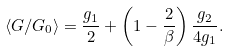Convert formula to latex. <formula><loc_0><loc_0><loc_500><loc_500>\langle G / G _ { 0 } \rangle = \frac { g _ { 1 } } { 2 } + \left ( 1 - \frac { 2 } { \beta } \right ) \frac { g _ { 2 } } { 4 g _ { 1 } } .</formula> 